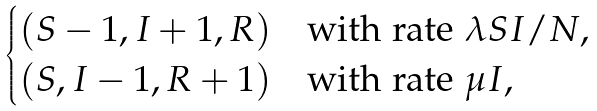<formula> <loc_0><loc_0><loc_500><loc_500>\begin{cases} ( S - 1 , I + 1 , R ) & \text {with rate} \ \lambda S I / N , \\ ( S , I - 1 , R + 1 ) & \text {with rate} \ \mu I , \end{cases}</formula> 